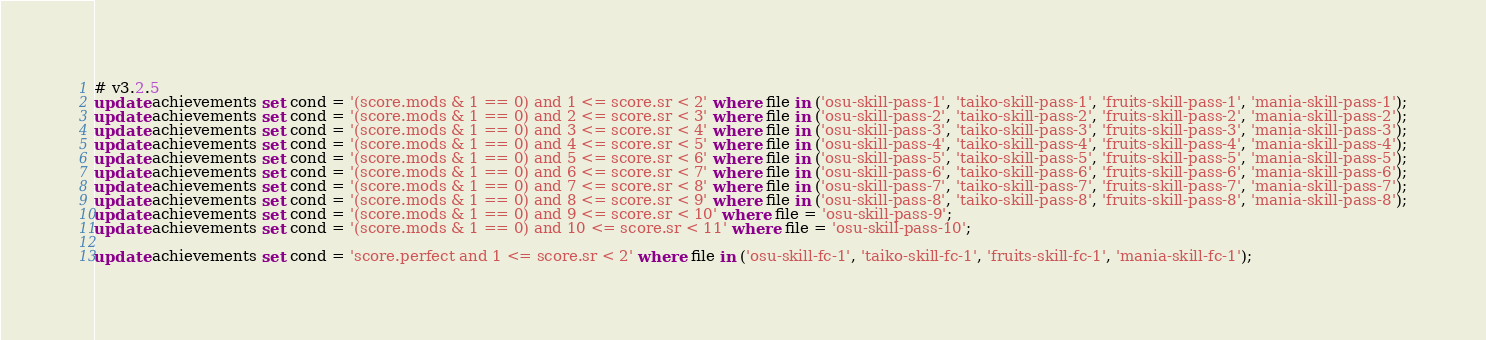Convert code to text. <code><loc_0><loc_0><loc_500><loc_500><_SQL_># v3.2.5
update achievements set cond = '(score.mods & 1 == 0) and 1 <= score.sr < 2' where file in ('osu-skill-pass-1', 'taiko-skill-pass-1', 'fruits-skill-pass-1', 'mania-skill-pass-1');
update achievements set cond = '(score.mods & 1 == 0) and 2 <= score.sr < 3' where file in ('osu-skill-pass-2', 'taiko-skill-pass-2', 'fruits-skill-pass-2', 'mania-skill-pass-2');
update achievements set cond = '(score.mods & 1 == 0) and 3 <= score.sr < 4' where file in ('osu-skill-pass-3', 'taiko-skill-pass-3', 'fruits-skill-pass-3', 'mania-skill-pass-3');
update achievements set cond = '(score.mods & 1 == 0) and 4 <= score.sr < 5' where file in ('osu-skill-pass-4', 'taiko-skill-pass-4', 'fruits-skill-pass-4', 'mania-skill-pass-4');
update achievements set cond = '(score.mods & 1 == 0) and 5 <= score.sr < 6' where file in ('osu-skill-pass-5', 'taiko-skill-pass-5', 'fruits-skill-pass-5', 'mania-skill-pass-5');
update achievements set cond = '(score.mods & 1 == 0) and 6 <= score.sr < 7' where file in ('osu-skill-pass-6', 'taiko-skill-pass-6', 'fruits-skill-pass-6', 'mania-skill-pass-6');
update achievements set cond = '(score.mods & 1 == 0) and 7 <= score.sr < 8' where file in ('osu-skill-pass-7', 'taiko-skill-pass-7', 'fruits-skill-pass-7', 'mania-skill-pass-7');
update achievements set cond = '(score.mods & 1 == 0) and 8 <= score.sr < 9' where file in ('osu-skill-pass-8', 'taiko-skill-pass-8', 'fruits-skill-pass-8', 'mania-skill-pass-8');
update achievements set cond = '(score.mods & 1 == 0) and 9 <= score.sr < 10' where file = 'osu-skill-pass-9';
update achievements set cond = '(score.mods & 1 == 0) and 10 <= score.sr < 11' where file = 'osu-skill-pass-10';

update achievements set cond = 'score.perfect and 1 <= score.sr < 2' where file in ('osu-skill-fc-1', 'taiko-skill-fc-1', 'fruits-skill-fc-1', 'mania-skill-fc-1');</code> 